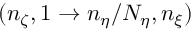<formula> <loc_0><loc_0><loc_500><loc_500>( n _ { \zeta } , 1 \rightarrow n _ { \eta } / N _ { \eta } , n _ { \xi } )</formula> 